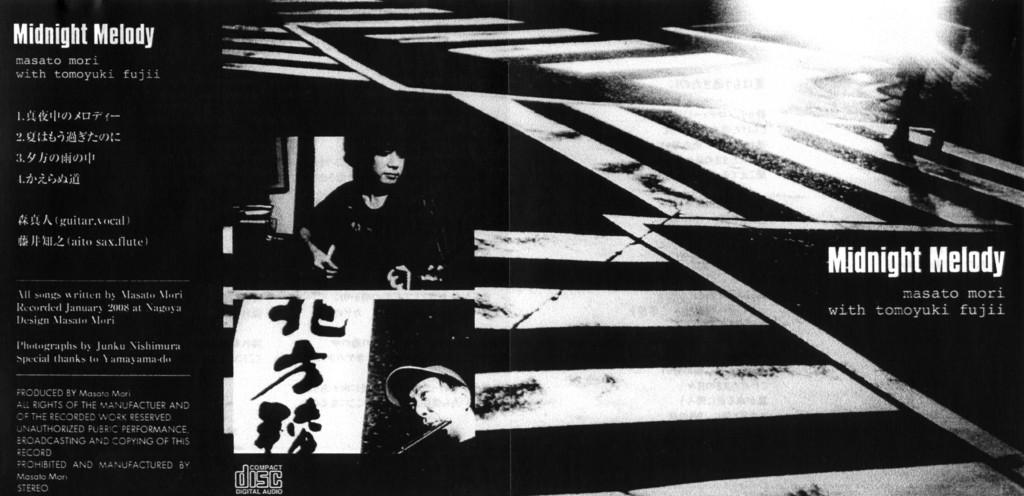<image>
Render a clear and concise summary of the photo. Business card in black and white that says Midnight Melody on top. 